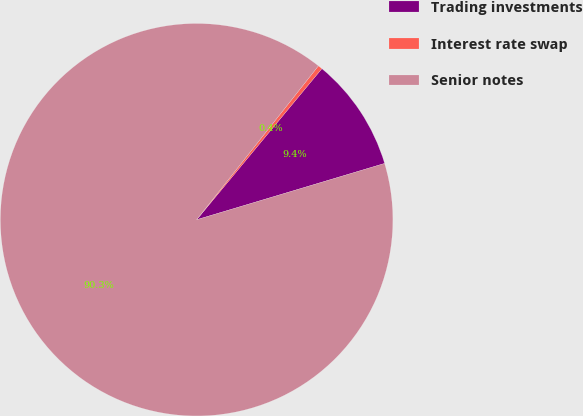Convert chart to OTSL. <chart><loc_0><loc_0><loc_500><loc_500><pie_chart><fcel>Trading investments<fcel>Interest rate swap<fcel>Senior notes<nl><fcel>9.35%<fcel>0.36%<fcel>90.29%<nl></chart> 